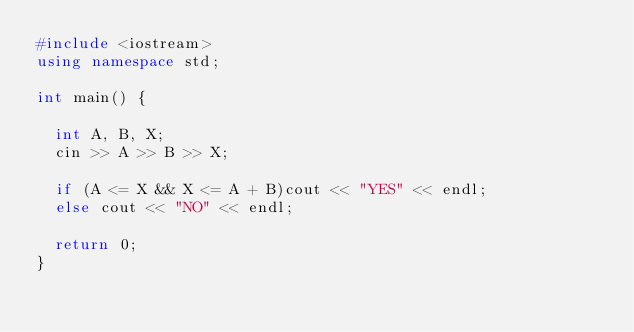Convert code to text. <code><loc_0><loc_0><loc_500><loc_500><_C++_>#include <iostream>
using namespace std;

int main() {

	int A, B, X;
	cin >> A >> B >> X;

	if (A <= X && X <= A + B)cout << "YES" << endl;
	else cout << "NO" << endl;

	return 0;
}</code> 